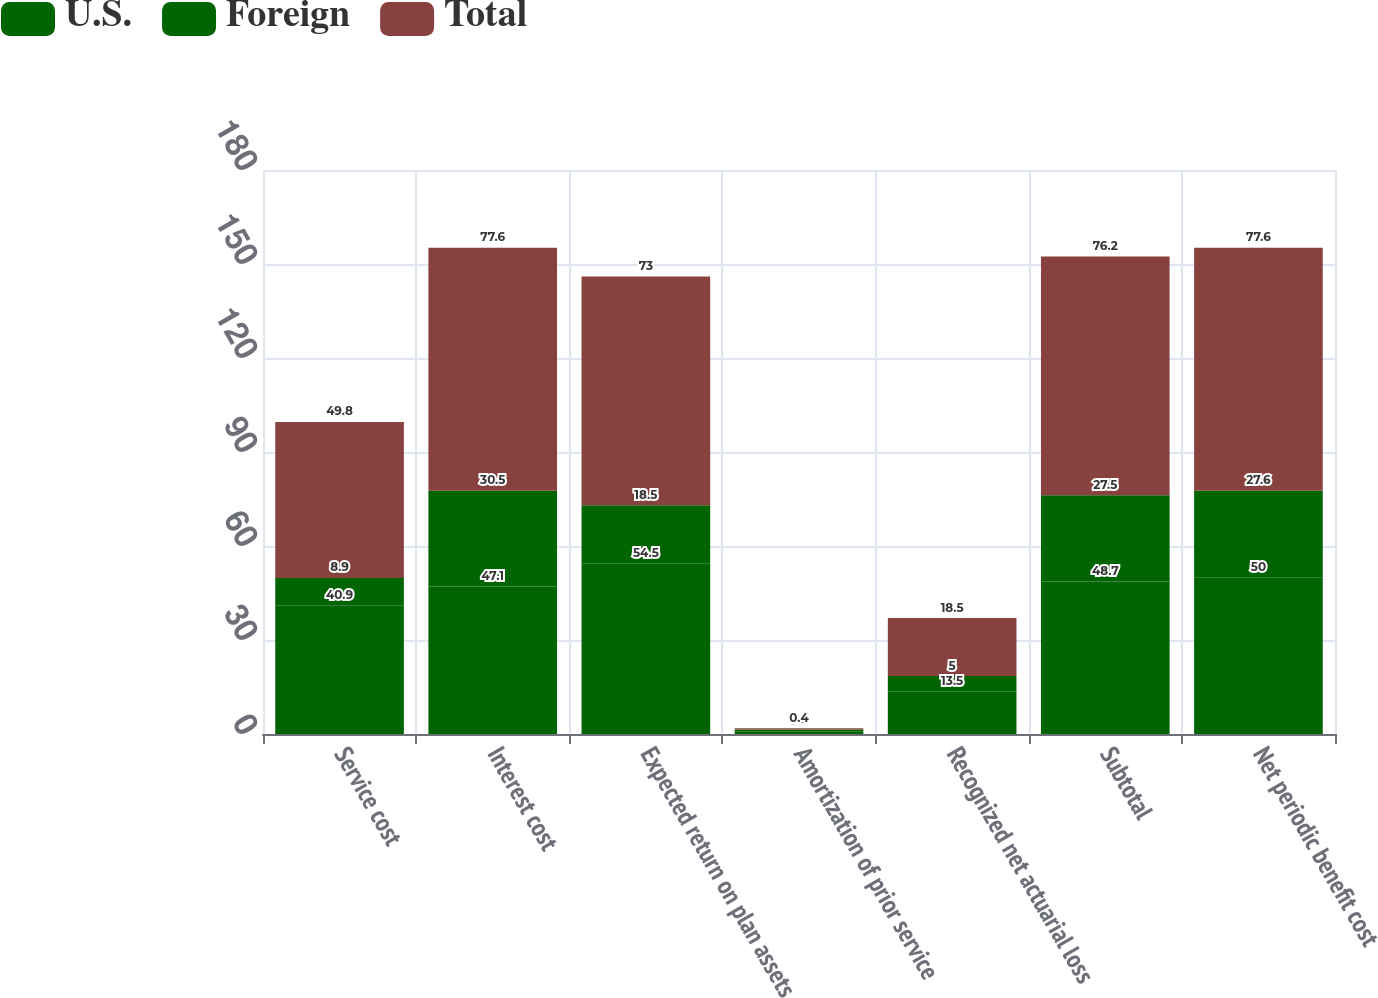Convert chart. <chart><loc_0><loc_0><loc_500><loc_500><stacked_bar_chart><ecel><fcel>Service cost<fcel>Interest cost<fcel>Expected return on plan assets<fcel>Amortization of prior service<fcel>Recognized net actuarial loss<fcel>Subtotal<fcel>Net periodic benefit cost<nl><fcel>U.S.<fcel>40.9<fcel>47.1<fcel>54.5<fcel>0.9<fcel>13.5<fcel>48.7<fcel>50<nl><fcel>Foreign<fcel>8.9<fcel>30.5<fcel>18.5<fcel>0.5<fcel>5<fcel>27.5<fcel>27.6<nl><fcel>Total<fcel>49.8<fcel>77.6<fcel>73<fcel>0.4<fcel>18.5<fcel>76.2<fcel>77.6<nl></chart> 